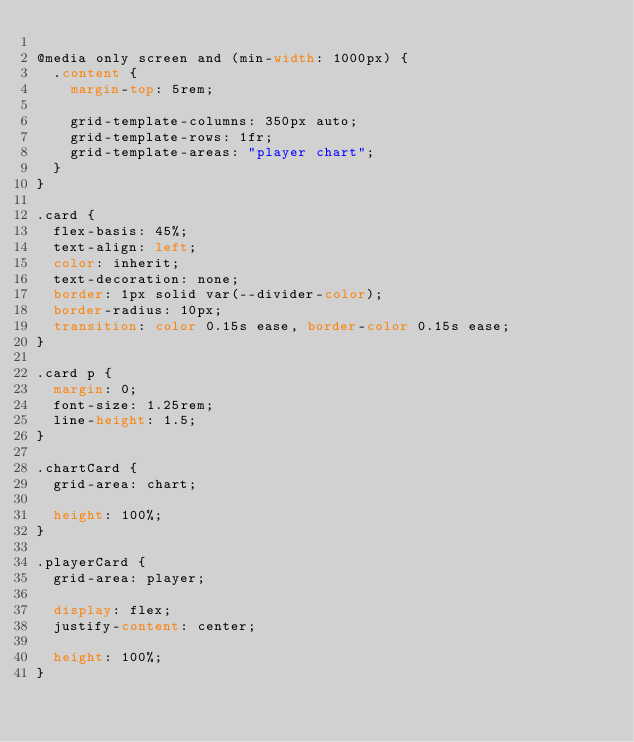<code> <loc_0><loc_0><loc_500><loc_500><_CSS_>
@media only screen and (min-width: 1000px) {
  .content {
    margin-top: 5rem;

    grid-template-columns: 350px auto;
    grid-template-rows: 1fr;
    grid-template-areas: "player chart";
  }
}

.card {
  flex-basis: 45%;
  text-align: left;
  color: inherit;
  text-decoration: none;
  border: 1px solid var(--divider-color);
  border-radius: 10px;
  transition: color 0.15s ease, border-color 0.15s ease;
}

.card p {
  margin: 0;
  font-size: 1.25rem;
  line-height: 1.5;
}

.chartCard {
  grid-area: chart;

  height: 100%;
}

.playerCard {
  grid-area: player;

  display: flex;
  justify-content: center;

  height: 100%;
}
</code> 